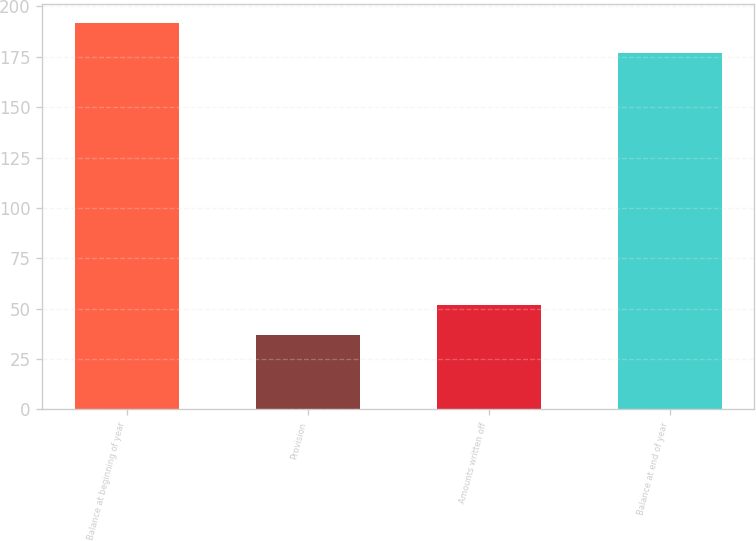Convert chart to OTSL. <chart><loc_0><loc_0><loc_500><loc_500><bar_chart><fcel>Balance at beginning of year<fcel>Provision<fcel>Amounts written off<fcel>Balance at end of year<nl><fcel>191.8<fcel>37<fcel>51.8<fcel>177<nl></chart> 